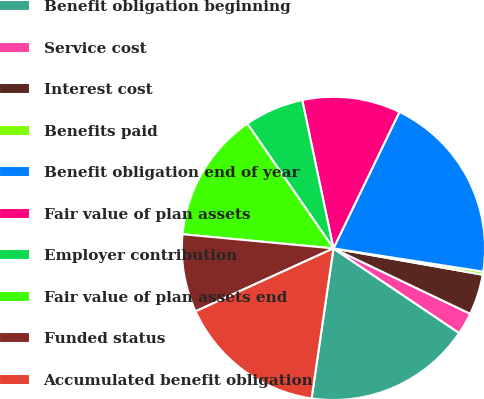<chart> <loc_0><loc_0><loc_500><loc_500><pie_chart><fcel>Benefit obligation beginning<fcel>Service cost<fcel>Interest cost<fcel>Benefits paid<fcel>Benefit obligation end of year<fcel>Fair value of plan assets<fcel>Employer contribution<fcel>Fair value of plan assets end<fcel>Funded status<fcel>Accumulated benefit obligation<nl><fcel>17.88%<fcel>2.33%<fcel>4.32%<fcel>0.33%<fcel>20.28%<fcel>10.47%<fcel>6.32%<fcel>13.89%<fcel>8.31%<fcel>15.88%<nl></chart> 